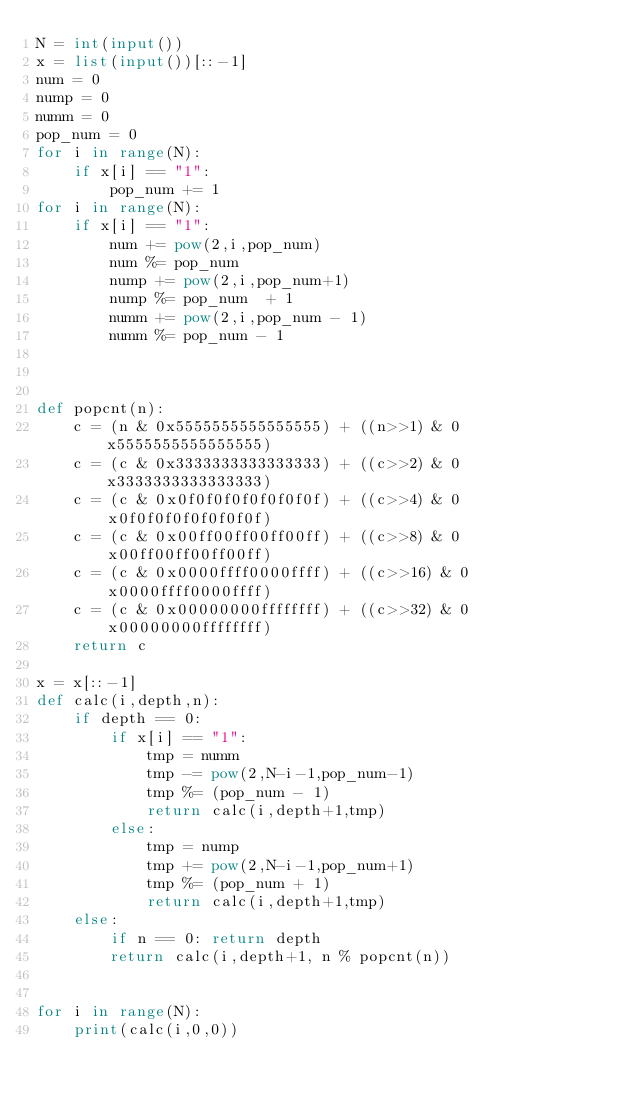Convert code to text. <code><loc_0><loc_0><loc_500><loc_500><_Python_>N = int(input())
x = list(input())[::-1]
num = 0
nump = 0
numm = 0
pop_num = 0
for i in range(N):
    if x[i] == "1":
        pop_num += 1
for i in range(N):
    if x[i] == "1":
        num += pow(2,i,pop_num)
        num %= pop_num 
        nump += pow(2,i,pop_num+1)
        nump %= pop_num  + 1
        numm += pow(2,i,pop_num - 1)
        numm %= pop_num - 1



def popcnt(n):
    c = (n & 0x5555555555555555) + ((n>>1) & 0x5555555555555555)
    c = (c & 0x3333333333333333) + ((c>>2) & 0x3333333333333333)
    c = (c & 0x0f0f0f0f0f0f0f0f) + ((c>>4) & 0x0f0f0f0f0f0f0f0f)
    c = (c & 0x00ff00ff00ff00ff) + ((c>>8) & 0x00ff00ff00ff00ff)
    c = (c & 0x0000ffff0000ffff) + ((c>>16) & 0x0000ffff0000ffff)
    c = (c & 0x00000000ffffffff) + ((c>>32) & 0x00000000ffffffff)
    return c

x = x[::-1]
def calc(i,depth,n):
    if depth == 0:
        if x[i] == "1":
            tmp = numm
            tmp -= pow(2,N-i-1,pop_num-1)
            tmp %= (pop_num - 1)
            return calc(i,depth+1,tmp)
        else:
            tmp = nump
            tmp += pow(2,N-i-1,pop_num+1)
            tmp %= (pop_num + 1)
            return calc(i,depth+1,tmp)
    else:
        if n == 0: return depth
        return calc(i,depth+1, n % popcnt(n))
        

for i in range(N):
    print(calc(i,0,0))

</code> 